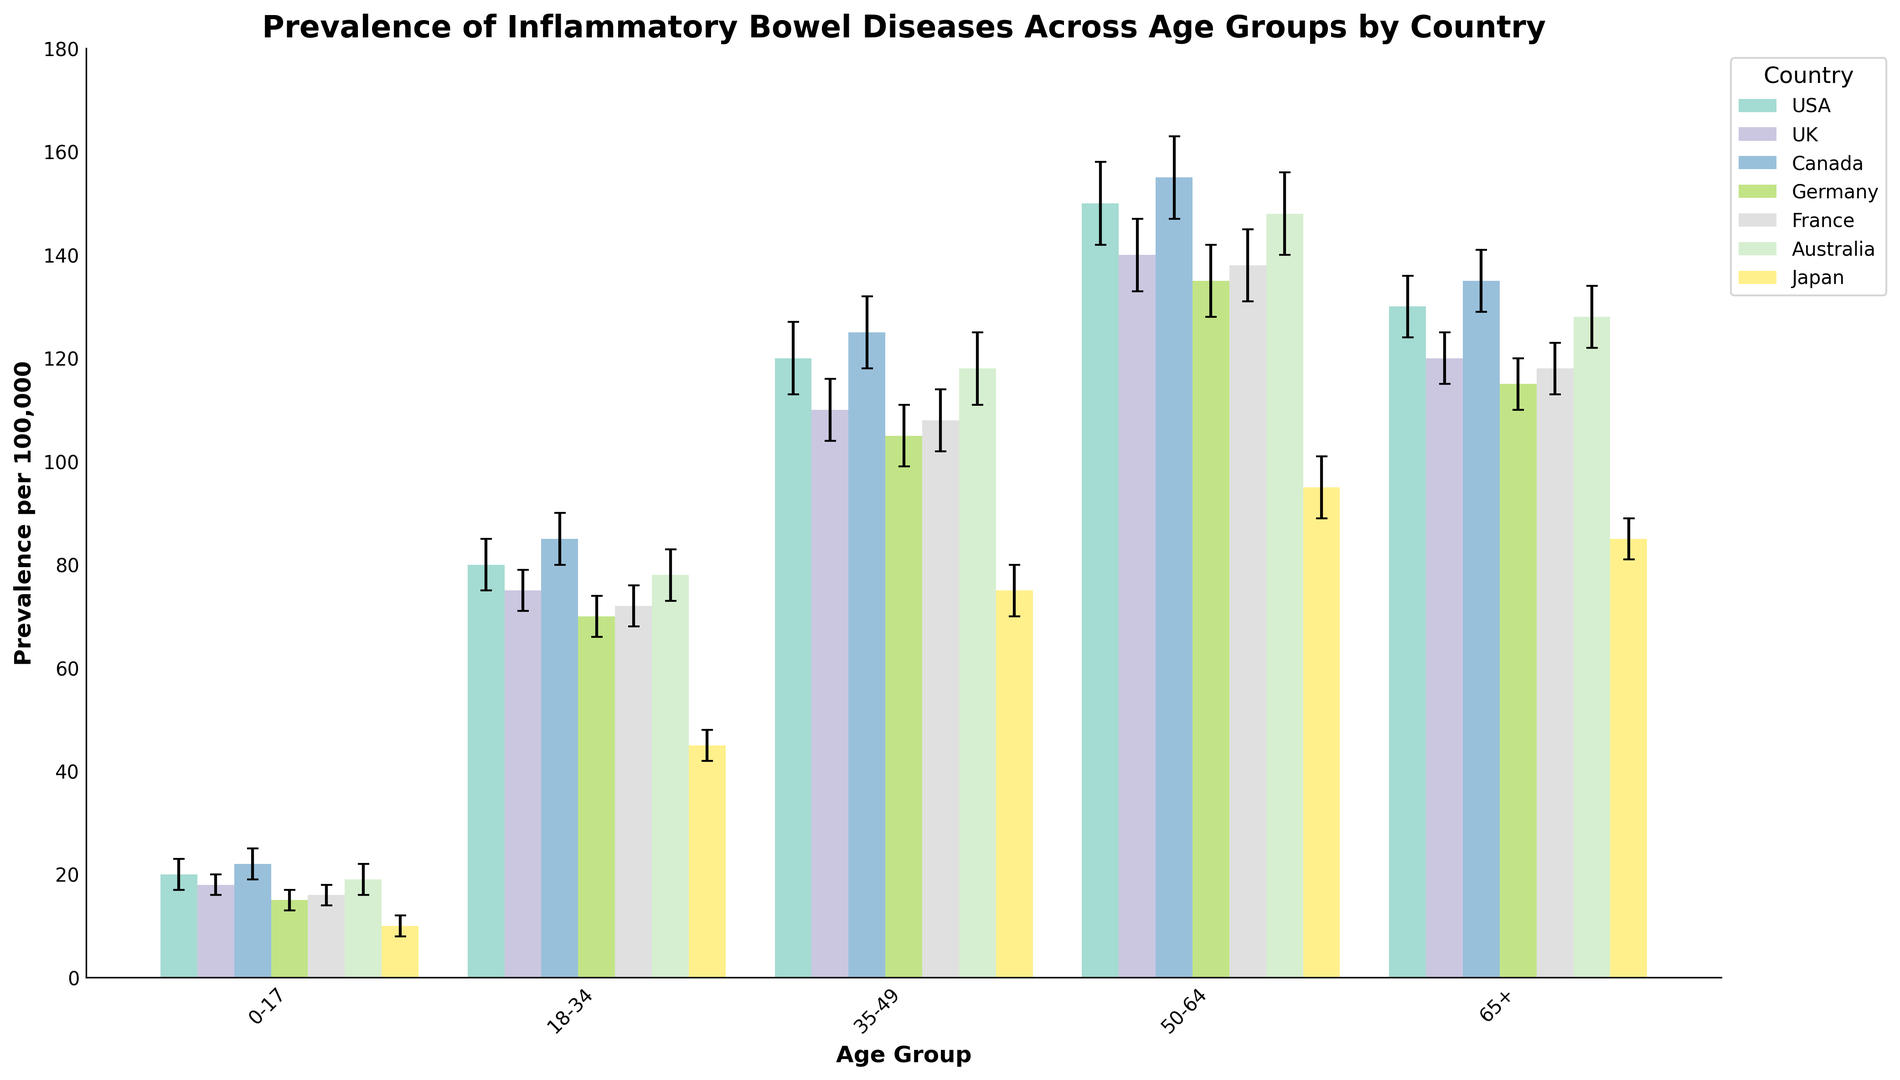What is the total prevalence of inflammatory bowel diseases in the 18-34 age group across all countries? To find the total prevalence in the 18-34 age group, sum the prevalence for each country: USA (80) + UK (75) + Canada (85) + Germany (70) + France (72) + Australia (78) + Japan (45) = 505
Answer: 505 Which country has the highest prevalence of inflammatory bowel diseases in the 50-64 age group? Compare the prevalence for the 50-64 age group across all countries: USA (150), UK (140), Canada (155), Germany (135), France (138), Australia (148), Japan (95). The highest value is 155 in Canada
Answer: Canada How does the prevalence of inflammatory bowel diseases in the 0-17 age group in Japan compare to that in Germany? Compare the heights of the bars for the 0-17 age group in Japan and Germany. Japan has 10 cases per 100,000 and Germany has 15 cases per 100,000
Answer: Japan has lower prevalence What is the average prevalence of inflammatory bowel diseases in the 65+ age group in UK and Australia? To find the average, sum the prevalence for UK (120) and Australia (128) and divide by 2: (120 + 128) / 2 = 124
Answer: 124 In which age group does USA show the highest prevalence of inflammatory bowel diseases? Check the prevalence values across all age groups for USA: 0-17 (20), 18-34 (80), 35-49 (120), 50-64 (150), 65+ (130). The highest prevalence is 150 in the 50-64 age group
Answer: 50-64 Compare the error margins for prevalence of inflammatory bowel diseases in the 18-34 age group in USA and Australia. Identify the error margins for the 18-34 age group in both countries: USA (5) and Australia (5). Both have the same error margin
Answer: Same What is the sum of error margins for the 35-49 age group across all countries? Sum the error margins for the 35-49 age group: USA (7) + UK (6) + Canada (7) + Germany (6) + France (6) + Australia (7) + Japan (5) = 44
Answer: 44 Which age group in France shows a lower prevalence of inflammatory bowel diseases compared to the same age group in Canada but higher than in Japan? Compare the prevalence of each age group between France, Canada, and Japan. The age groups to consider are: 0-17 (France: 16, Canada: 22, Japan: 10), 18-34 (France: 72, Canada: 85, Japan: 45), and so on. The 18-34 age group fits this condition (72 in France, 85 in Canada, 45 in Japan)
Answer: 18-34 